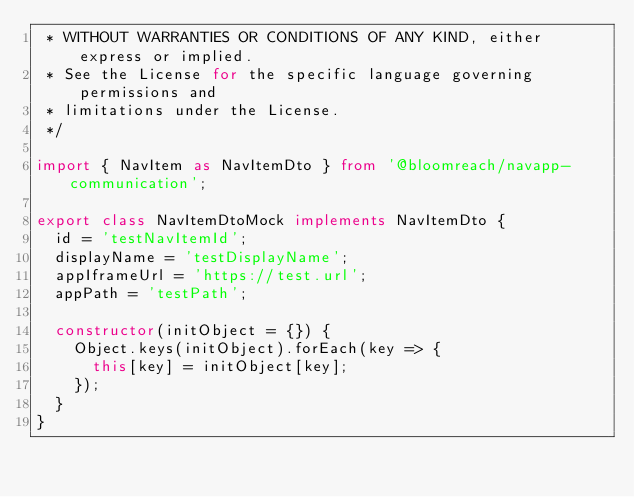Convert code to text. <code><loc_0><loc_0><loc_500><loc_500><_TypeScript_> * WITHOUT WARRANTIES OR CONDITIONS OF ANY KIND, either express or implied.
 * See the License for the specific language governing permissions and
 * limitations under the License.
 */

import { NavItem as NavItemDto } from '@bloomreach/navapp-communication';

export class NavItemDtoMock implements NavItemDto {
  id = 'testNavItemId';
  displayName = 'testDisplayName';
  appIframeUrl = 'https://test.url';
  appPath = 'testPath';

  constructor(initObject = {}) {
    Object.keys(initObject).forEach(key => {
      this[key] = initObject[key];
    });
  }
}
</code> 